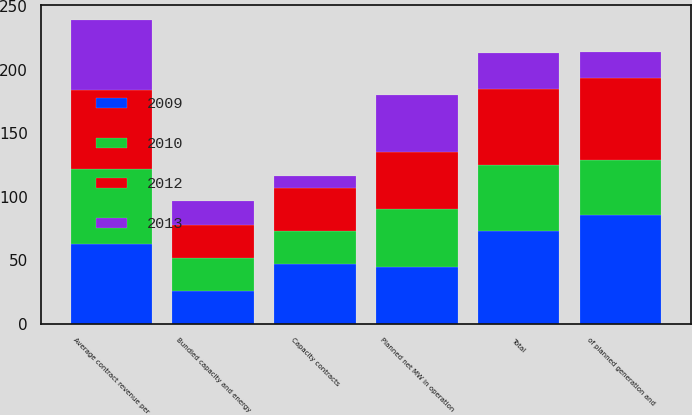Convert chart to OTSL. <chart><loc_0><loc_0><loc_500><loc_500><stacked_bar_chart><ecel><fcel>Bundled capacity and energy<fcel>Capacity contracts<fcel>Total<fcel>Planned net MW in operation<fcel>of planned generation and<fcel>Average contract revenue per<nl><fcel>2009<fcel>26<fcel>47<fcel>73<fcel>45<fcel>86<fcel>63<nl><fcel>2012<fcel>26<fcel>34<fcel>60<fcel>45<fcel>64<fcel>62<nl><fcel>2010<fcel>26<fcel>26<fcel>52<fcel>45<fcel>43<fcel>59<nl><fcel>2013<fcel>19<fcel>9<fcel>28<fcel>45<fcel>21<fcel>55<nl></chart> 